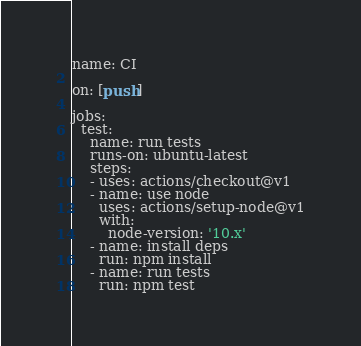Convert code to text. <code><loc_0><loc_0><loc_500><loc_500><_YAML_>name: CI

on: [push]

jobs:
  test:
    name: run tests
    runs-on: ubuntu-latest
    steps:
    - uses: actions/checkout@v1
    - name: use node
      uses: actions/setup-node@v1
      with:
        node-version: '10.x'
    - name: install deps
      run: npm install
    - name: run tests
      run: npm test
</code> 